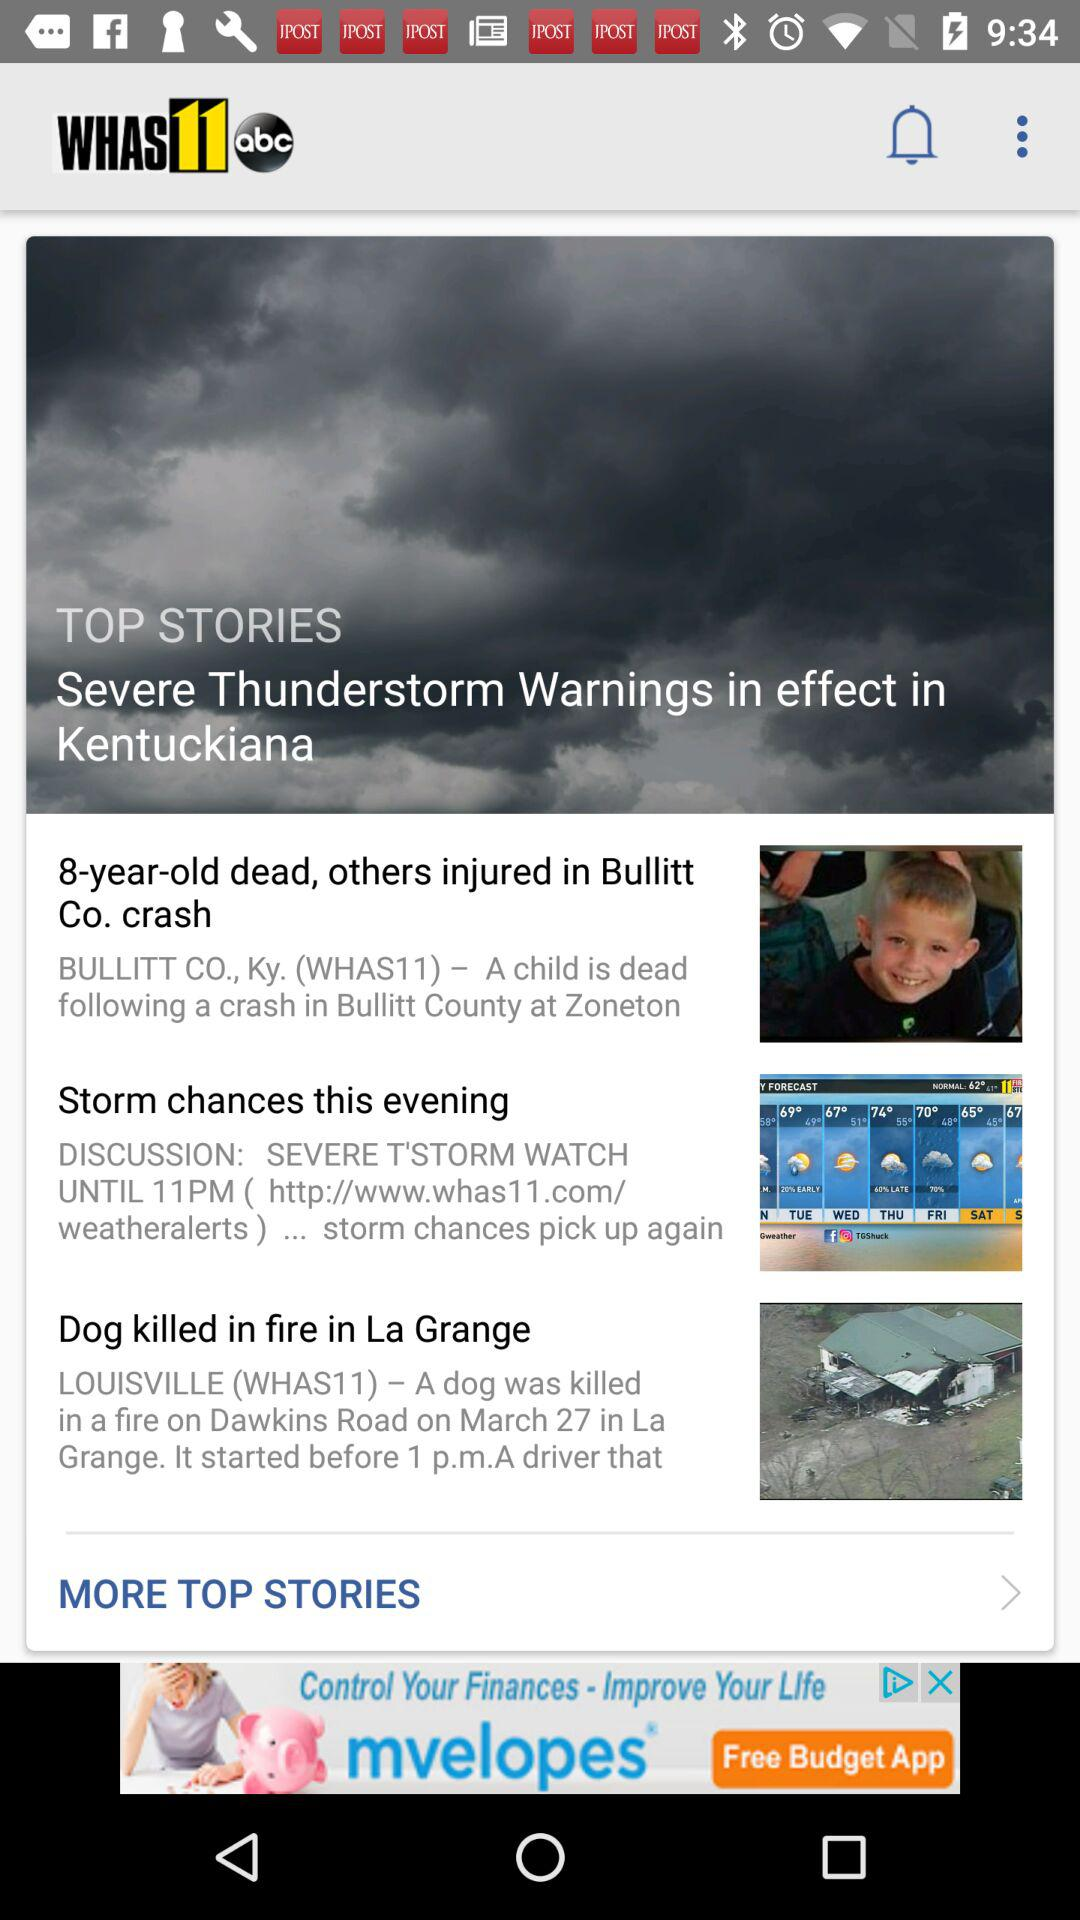What is the application name? The application name is "WHAS11". 